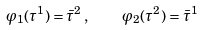<formula> <loc_0><loc_0><loc_500><loc_500>\varphi _ { 1 } ( \tau ^ { 1 } ) = \bar { \tau } ^ { 2 } \, , \quad \varphi _ { 2 } ( \tau ^ { 2 } ) = \bar { \tau } ^ { 1 }</formula> 